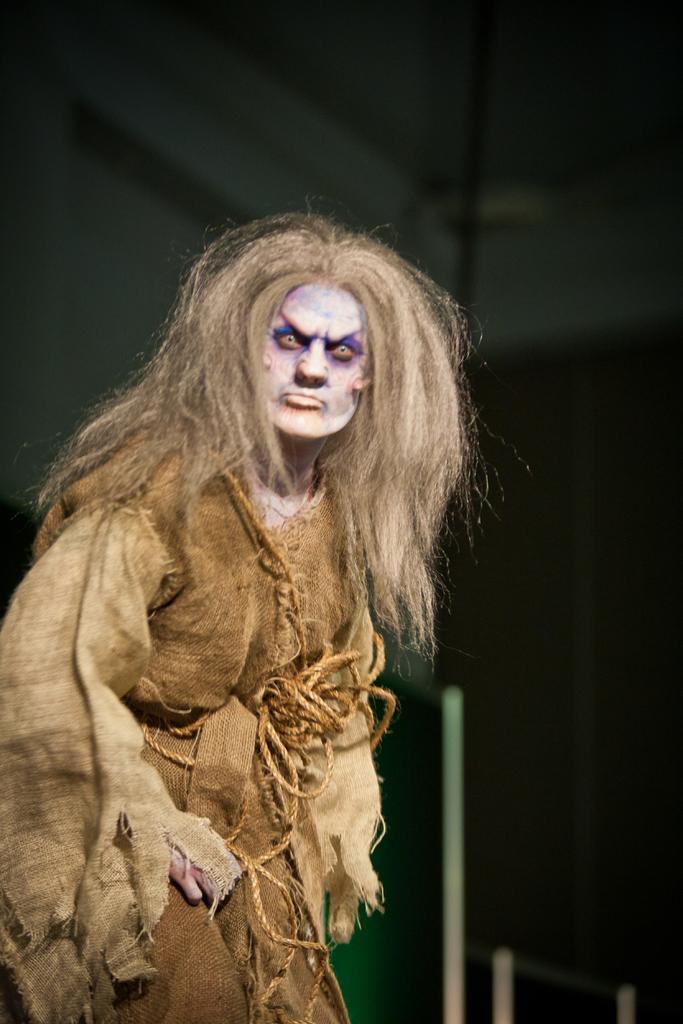Can you describe this image briefly? On the left side of the image we can see a person is wearing costume. In the background of the image we can see the wall. At the top of the image we can see the roof. 